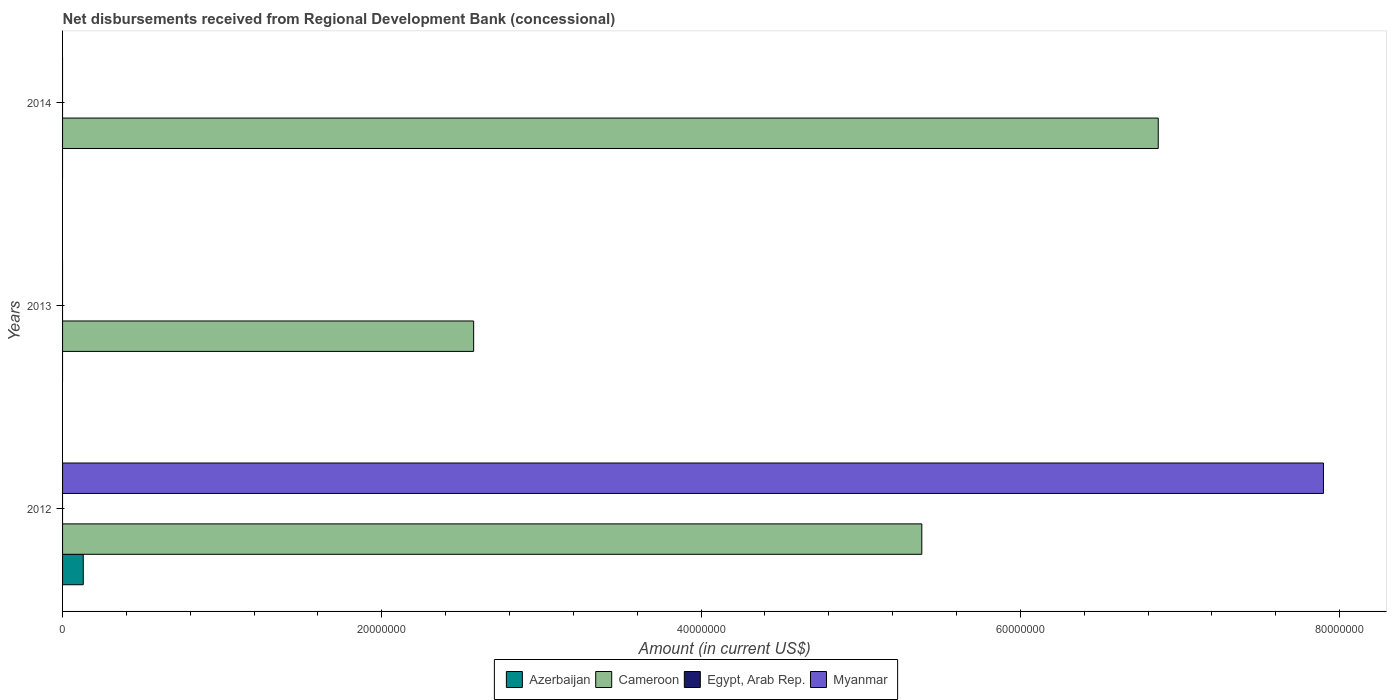How many different coloured bars are there?
Keep it short and to the point. 3. Are the number of bars per tick equal to the number of legend labels?
Give a very brief answer. No. Are the number of bars on each tick of the Y-axis equal?
Your answer should be compact. No. How many bars are there on the 2nd tick from the top?
Your answer should be very brief. 1. What is the label of the 2nd group of bars from the top?
Give a very brief answer. 2013. In how many cases, is the number of bars for a given year not equal to the number of legend labels?
Provide a succinct answer. 3. Across all years, what is the maximum amount of disbursements received from Regional Development Bank in Myanmar?
Make the answer very short. 7.90e+07. Across all years, what is the minimum amount of disbursements received from Regional Development Bank in Cameroon?
Your response must be concise. 2.58e+07. What is the total amount of disbursements received from Regional Development Bank in Myanmar in the graph?
Your response must be concise. 7.90e+07. What is the difference between the amount of disbursements received from Regional Development Bank in Cameroon in 2013 and that in 2014?
Offer a terse response. -4.29e+07. What is the difference between the amount of disbursements received from Regional Development Bank in Egypt, Arab Rep. in 2014 and the amount of disbursements received from Regional Development Bank in Cameroon in 2012?
Your answer should be compact. -5.38e+07. What is the average amount of disbursements received from Regional Development Bank in Cameroon per year?
Keep it short and to the point. 4.94e+07. In the year 2012, what is the difference between the amount of disbursements received from Regional Development Bank in Cameroon and amount of disbursements received from Regional Development Bank in Azerbaijan?
Your answer should be very brief. 5.25e+07. What is the ratio of the amount of disbursements received from Regional Development Bank in Cameroon in 2012 to that in 2013?
Provide a succinct answer. 2.09. What is the difference between the highest and the lowest amount of disbursements received from Regional Development Bank in Myanmar?
Offer a very short reply. 7.90e+07. Is the sum of the amount of disbursements received from Regional Development Bank in Cameroon in 2012 and 2013 greater than the maximum amount of disbursements received from Regional Development Bank in Myanmar across all years?
Ensure brevity in your answer.  Yes. Is it the case that in every year, the sum of the amount of disbursements received from Regional Development Bank in Cameroon and amount of disbursements received from Regional Development Bank in Myanmar is greater than the amount of disbursements received from Regional Development Bank in Egypt, Arab Rep.?
Your answer should be compact. Yes. Are all the bars in the graph horizontal?
Your answer should be very brief. Yes. What is the difference between two consecutive major ticks on the X-axis?
Ensure brevity in your answer.  2.00e+07. Where does the legend appear in the graph?
Your answer should be very brief. Bottom center. How many legend labels are there?
Your response must be concise. 4. What is the title of the graph?
Keep it short and to the point. Net disbursements received from Regional Development Bank (concessional). What is the label or title of the X-axis?
Your answer should be compact. Amount (in current US$). What is the Amount (in current US$) in Azerbaijan in 2012?
Offer a very short reply. 1.30e+06. What is the Amount (in current US$) of Cameroon in 2012?
Provide a succinct answer. 5.38e+07. What is the Amount (in current US$) in Myanmar in 2012?
Keep it short and to the point. 7.90e+07. What is the Amount (in current US$) of Cameroon in 2013?
Provide a succinct answer. 2.58e+07. What is the Amount (in current US$) of Egypt, Arab Rep. in 2013?
Keep it short and to the point. 0. What is the Amount (in current US$) of Cameroon in 2014?
Your answer should be very brief. 6.86e+07. Across all years, what is the maximum Amount (in current US$) in Azerbaijan?
Provide a short and direct response. 1.30e+06. Across all years, what is the maximum Amount (in current US$) in Cameroon?
Give a very brief answer. 6.86e+07. Across all years, what is the maximum Amount (in current US$) in Myanmar?
Provide a short and direct response. 7.90e+07. Across all years, what is the minimum Amount (in current US$) of Azerbaijan?
Offer a terse response. 0. Across all years, what is the minimum Amount (in current US$) of Cameroon?
Make the answer very short. 2.58e+07. What is the total Amount (in current US$) of Azerbaijan in the graph?
Offer a very short reply. 1.30e+06. What is the total Amount (in current US$) in Cameroon in the graph?
Offer a terse response. 1.48e+08. What is the total Amount (in current US$) of Myanmar in the graph?
Provide a succinct answer. 7.90e+07. What is the difference between the Amount (in current US$) in Cameroon in 2012 and that in 2013?
Ensure brevity in your answer.  2.81e+07. What is the difference between the Amount (in current US$) in Cameroon in 2012 and that in 2014?
Offer a very short reply. -1.48e+07. What is the difference between the Amount (in current US$) of Cameroon in 2013 and that in 2014?
Ensure brevity in your answer.  -4.29e+07. What is the difference between the Amount (in current US$) of Azerbaijan in 2012 and the Amount (in current US$) of Cameroon in 2013?
Keep it short and to the point. -2.45e+07. What is the difference between the Amount (in current US$) in Azerbaijan in 2012 and the Amount (in current US$) in Cameroon in 2014?
Provide a short and direct response. -6.73e+07. What is the average Amount (in current US$) of Azerbaijan per year?
Give a very brief answer. 4.32e+05. What is the average Amount (in current US$) in Cameroon per year?
Your response must be concise. 4.94e+07. What is the average Amount (in current US$) of Myanmar per year?
Your answer should be compact. 2.63e+07. In the year 2012, what is the difference between the Amount (in current US$) of Azerbaijan and Amount (in current US$) of Cameroon?
Keep it short and to the point. -5.25e+07. In the year 2012, what is the difference between the Amount (in current US$) in Azerbaijan and Amount (in current US$) in Myanmar?
Your answer should be compact. -7.77e+07. In the year 2012, what is the difference between the Amount (in current US$) in Cameroon and Amount (in current US$) in Myanmar?
Provide a succinct answer. -2.52e+07. What is the ratio of the Amount (in current US$) in Cameroon in 2012 to that in 2013?
Offer a terse response. 2.09. What is the ratio of the Amount (in current US$) of Cameroon in 2012 to that in 2014?
Offer a very short reply. 0.78. What is the ratio of the Amount (in current US$) of Cameroon in 2013 to that in 2014?
Provide a succinct answer. 0.38. What is the difference between the highest and the second highest Amount (in current US$) in Cameroon?
Offer a terse response. 1.48e+07. What is the difference between the highest and the lowest Amount (in current US$) of Azerbaijan?
Your answer should be very brief. 1.30e+06. What is the difference between the highest and the lowest Amount (in current US$) of Cameroon?
Your answer should be very brief. 4.29e+07. What is the difference between the highest and the lowest Amount (in current US$) in Myanmar?
Your response must be concise. 7.90e+07. 